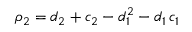<formula> <loc_0><loc_0><loc_500><loc_500>\rho _ { 2 } = d _ { 2 } + c _ { 2 } - d _ { 1 } ^ { 2 } - d _ { 1 } \, c _ { 1 }</formula> 